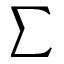<formula> <loc_0><loc_0><loc_500><loc_500>\sum</formula> 